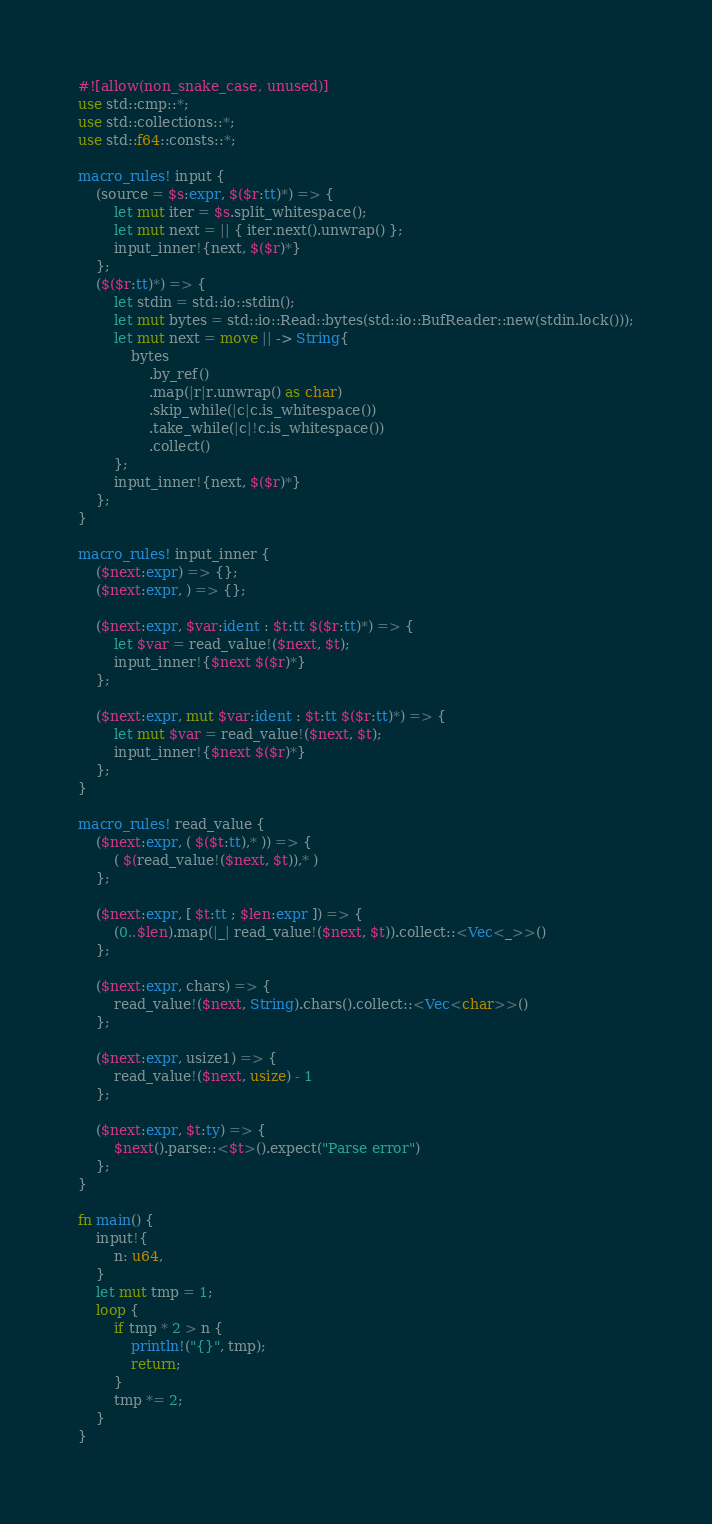<code> <loc_0><loc_0><loc_500><loc_500><_Rust_>#![allow(non_snake_case, unused)]
use std::cmp::*;
use std::collections::*;
use std::f64::consts::*;

macro_rules! input {
    (source = $s:expr, $($r:tt)*) => {
        let mut iter = $s.split_whitespace();
        let mut next = || { iter.next().unwrap() };
        input_inner!{next, $($r)*}
    };
    ($($r:tt)*) => {
        let stdin = std::io::stdin();
        let mut bytes = std::io::Read::bytes(std::io::BufReader::new(stdin.lock()));
        let mut next = move || -> String{
            bytes
                .by_ref()
                .map(|r|r.unwrap() as char)
                .skip_while(|c|c.is_whitespace())
                .take_while(|c|!c.is_whitespace())
                .collect()
        };
        input_inner!{next, $($r)*}
    };
}

macro_rules! input_inner {
    ($next:expr) => {};
    ($next:expr, ) => {};

    ($next:expr, $var:ident : $t:tt $($r:tt)*) => {
        let $var = read_value!($next, $t);
        input_inner!{$next $($r)*}
    };

    ($next:expr, mut $var:ident : $t:tt $($r:tt)*) => {
        let mut $var = read_value!($next, $t);
        input_inner!{$next $($r)*}
    };
}

macro_rules! read_value {
    ($next:expr, ( $($t:tt),* )) => {
        ( $(read_value!($next, $t)),* )
    };

    ($next:expr, [ $t:tt ; $len:expr ]) => {
        (0..$len).map(|_| read_value!($next, $t)).collect::<Vec<_>>()
    };

    ($next:expr, chars) => {
        read_value!($next, String).chars().collect::<Vec<char>>()
    };

    ($next:expr, usize1) => {
        read_value!($next, usize) - 1
    };

    ($next:expr, $t:ty) => {
        $next().parse::<$t>().expect("Parse error")
    };
}

fn main() {
    input!{
        n: u64,
    }
    let mut tmp = 1;
    loop {
        if tmp * 2 > n {
            println!("{}", tmp);
            return;
        }
        tmp *= 2;
    }
}
</code> 